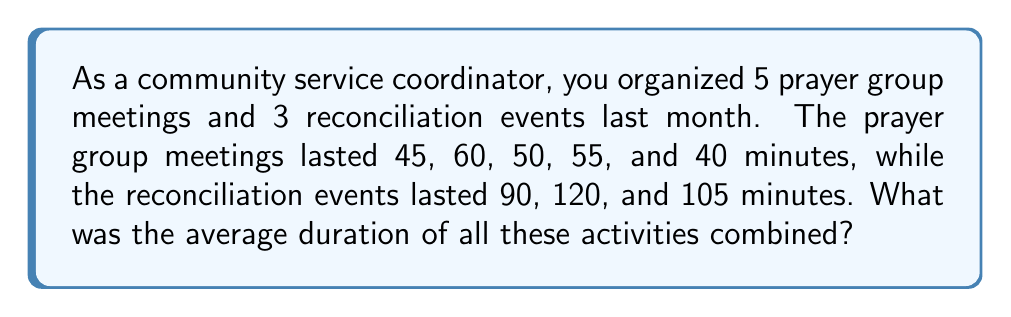Could you help me with this problem? To find the average duration of all activities combined, we need to:
1. Calculate the total duration of all activities
2. Count the total number of activities
3. Divide the total duration by the number of activities

Step 1: Calculate the total duration
- Prayer group meetings: $45 + 60 + 50 + 55 + 40 = 250$ minutes
- Reconciliation events: $90 + 120 + 105 = 315$ minutes
- Total duration: $250 + 315 = 565$ minutes

Step 2: Count the total number of activities
- Prayer group meetings: 5
- Reconciliation events: 3
- Total number of activities: $5 + 3 = 8$

Step 3: Calculate the average
Average duration = Total duration ÷ Number of activities
$$\text{Average} = \frac{565}{8} = 70.625\text{ minutes}$$

Therefore, the average duration of all activities combined is 70.625 minutes.
Answer: $70.625$ minutes 